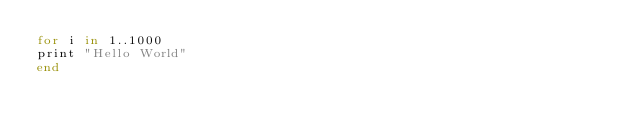Convert code to text. <code><loc_0><loc_0><loc_500><loc_500><_Ruby_>for i in 1..1000
print "Hello World"
end</code> 